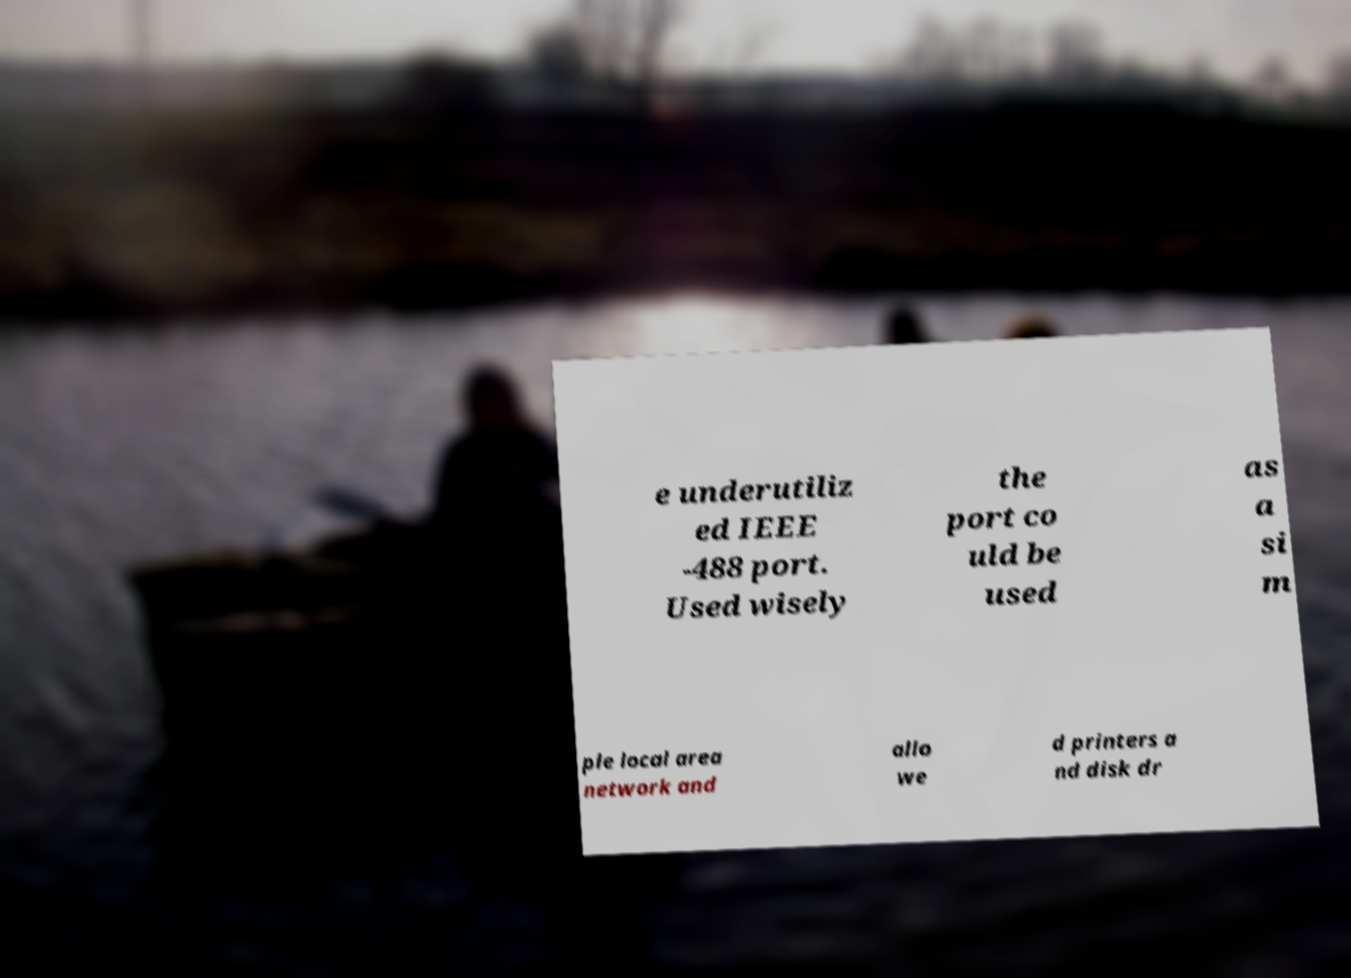Please read and relay the text visible in this image. What does it say? e underutiliz ed IEEE -488 port. Used wisely the port co uld be used as a si m ple local area network and allo we d printers a nd disk dr 